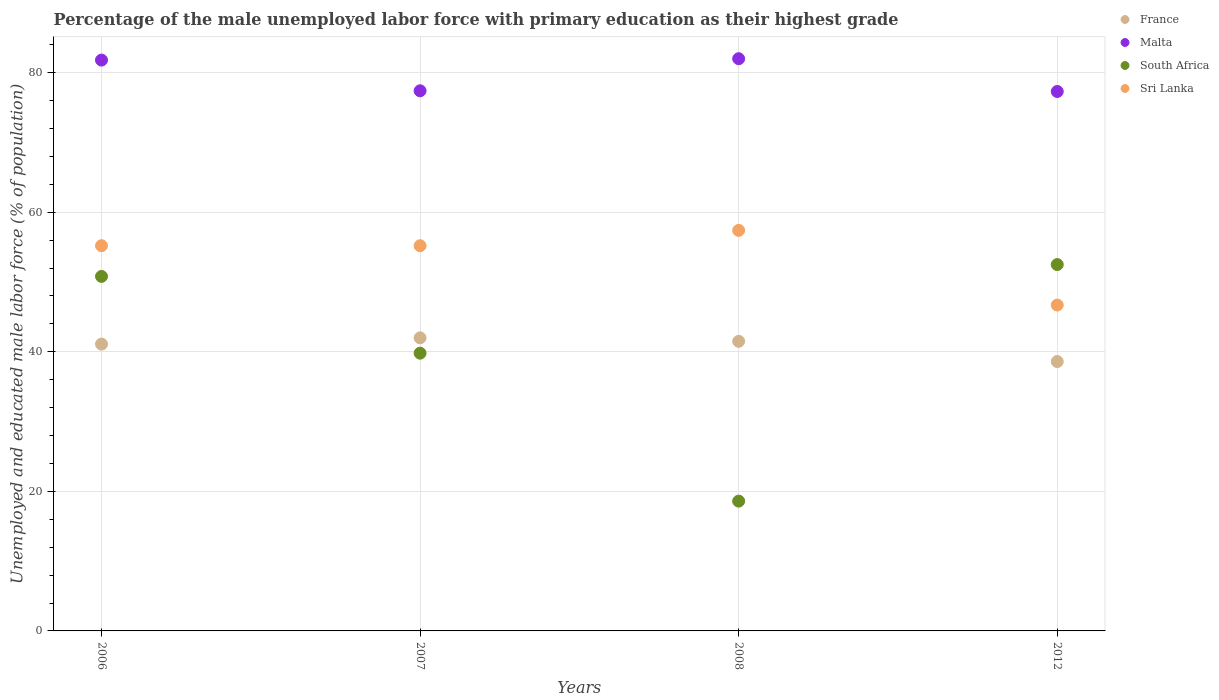Is the number of dotlines equal to the number of legend labels?
Offer a terse response. Yes. What is the percentage of the unemployed male labor force with primary education in Malta in 2006?
Offer a very short reply. 81.8. Across all years, what is the maximum percentage of the unemployed male labor force with primary education in South Africa?
Keep it short and to the point. 52.5. Across all years, what is the minimum percentage of the unemployed male labor force with primary education in Sri Lanka?
Provide a succinct answer. 46.7. In which year was the percentage of the unemployed male labor force with primary education in Sri Lanka maximum?
Make the answer very short. 2008. In which year was the percentage of the unemployed male labor force with primary education in Sri Lanka minimum?
Provide a short and direct response. 2012. What is the total percentage of the unemployed male labor force with primary education in Sri Lanka in the graph?
Your answer should be compact. 214.5. What is the difference between the percentage of the unemployed male labor force with primary education in France in 2006 and that in 2012?
Give a very brief answer. 2.5. What is the difference between the percentage of the unemployed male labor force with primary education in France in 2006 and the percentage of the unemployed male labor force with primary education in Sri Lanka in 2007?
Your response must be concise. -14.1. What is the average percentage of the unemployed male labor force with primary education in South Africa per year?
Offer a terse response. 40.42. In the year 2006, what is the difference between the percentage of the unemployed male labor force with primary education in France and percentage of the unemployed male labor force with primary education in South Africa?
Provide a succinct answer. -9.7. What is the ratio of the percentage of the unemployed male labor force with primary education in France in 2006 to that in 2008?
Ensure brevity in your answer.  0.99. Is the difference between the percentage of the unemployed male labor force with primary education in France in 2007 and 2012 greater than the difference between the percentage of the unemployed male labor force with primary education in South Africa in 2007 and 2012?
Ensure brevity in your answer.  Yes. What is the difference between the highest and the second highest percentage of the unemployed male labor force with primary education in Malta?
Your response must be concise. 0.2. What is the difference between the highest and the lowest percentage of the unemployed male labor force with primary education in South Africa?
Keep it short and to the point. 33.9. Is it the case that in every year, the sum of the percentage of the unemployed male labor force with primary education in South Africa and percentage of the unemployed male labor force with primary education in Malta  is greater than the sum of percentage of the unemployed male labor force with primary education in France and percentage of the unemployed male labor force with primary education in Sri Lanka?
Keep it short and to the point. Yes. Is it the case that in every year, the sum of the percentage of the unemployed male labor force with primary education in South Africa and percentage of the unemployed male labor force with primary education in Sri Lanka  is greater than the percentage of the unemployed male labor force with primary education in Malta?
Keep it short and to the point. No. Does the percentage of the unemployed male labor force with primary education in Sri Lanka monotonically increase over the years?
Your answer should be compact. No. How many dotlines are there?
Provide a short and direct response. 4. What is the difference between two consecutive major ticks on the Y-axis?
Your response must be concise. 20. Does the graph contain any zero values?
Provide a succinct answer. No. Does the graph contain grids?
Ensure brevity in your answer.  Yes. Where does the legend appear in the graph?
Provide a short and direct response. Top right. How are the legend labels stacked?
Offer a very short reply. Vertical. What is the title of the graph?
Your response must be concise. Percentage of the male unemployed labor force with primary education as their highest grade. What is the label or title of the Y-axis?
Ensure brevity in your answer.  Unemployed and educated male labor force (% of population). What is the Unemployed and educated male labor force (% of population) in France in 2006?
Give a very brief answer. 41.1. What is the Unemployed and educated male labor force (% of population) of Malta in 2006?
Ensure brevity in your answer.  81.8. What is the Unemployed and educated male labor force (% of population) of South Africa in 2006?
Your response must be concise. 50.8. What is the Unemployed and educated male labor force (% of population) in Sri Lanka in 2006?
Your answer should be compact. 55.2. What is the Unemployed and educated male labor force (% of population) of Malta in 2007?
Give a very brief answer. 77.4. What is the Unemployed and educated male labor force (% of population) in South Africa in 2007?
Provide a succinct answer. 39.8. What is the Unemployed and educated male labor force (% of population) in Sri Lanka in 2007?
Offer a very short reply. 55.2. What is the Unemployed and educated male labor force (% of population) in France in 2008?
Offer a very short reply. 41.5. What is the Unemployed and educated male labor force (% of population) of South Africa in 2008?
Keep it short and to the point. 18.6. What is the Unemployed and educated male labor force (% of population) in Sri Lanka in 2008?
Offer a very short reply. 57.4. What is the Unemployed and educated male labor force (% of population) in France in 2012?
Give a very brief answer. 38.6. What is the Unemployed and educated male labor force (% of population) in Malta in 2012?
Ensure brevity in your answer.  77.3. What is the Unemployed and educated male labor force (% of population) in South Africa in 2012?
Provide a succinct answer. 52.5. What is the Unemployed and educated male labor force (% of population) of Sri Lanka in 2012?
Your answer should be compact. 46.7. Across all years, what is the maximum Unemployed and educated male labor force (% of population) in Malta?
Your answer should be compact. 82. Across all years, what is the maximum Unemployed and educated male labor force (% of population) of South Africa?
Ensure brevity in your answer.  52.5. Across all years, what is the maximum Unemployed and educated male labor force (% of population) of Sri Lanka?
Give a very brief answer. 57.4. Across all years, what is the minimum Unemployed and educated male labor force (% of population) of France?
Ensure brevity in your answer.  38.6. Across all years, what is the minimum Unemployed and educated male labor force (% of population) of Malta?
Provide a succinct answer. 77.3. Across all years, what is the minimum Unemployed and educated male labor force (% of population) in South Africa?
Your answer should be compact. 18.6. Across all years, what is the minimum Unemployed and educated male labor force (% of population) in Sri Lanka?
Make the answer very short. 46.7. What is the total Unemployed and educated male labor force (% of population) of France in the graph?
Your answer should be very brief. 163.2. What is the total Unemployed and educated male labor force (% of population) in Malta in the graph?
Your answer should be compact. 318.5. What is the total Unemployed and educated male labor force (% of population) in South Africa in the graph?
Your response must be concise. 161.7. What is the total Unemployed and educated male labor force (% of population) in Sri Lanka in the graph?
Provide a short and direct response. 214.5. What is the difference between the Unemployed and educated male labor force (% of population) in Malta in 2006 and that in 2007?
Your answer should be very brief. 4.4. What is the difference between the Unemployed and educated male labor force (% of population) in Sri Lanka in 2006 and that in 2007?
Ensure brevity in your answer.  0. What is the difference between the Unemployed and educated male labor force (% of population) in France in 2006 and that in 2008?
Your answer should be very brief. -0.4. What is the difference between the Unemployed and educated male labor force (% of population) in Malta in 2006 and that in 2008?
Make the answer very short. -0.2. What is the difference between the Unemployed and educated male labor force (% of population) in South Africa in 2006 and that in 2008?
Offer a terse response. 32.2. What is the difference between the Unemployed and educated male labor force (% of population) in France in 2006 and that in 2012?
Provide a succinct answer. 2.5. What is the difference between the Unemployed and educated male labor force (% of population) of South Africa in 2006 and that in 2012?
Provide a succinct answer. -1.7. What is the difference between the Unemployed and educated male labor force (% of population) in Sri Lanka in 2006 and that in 2012?
Give a very brief answer. 8.5. What is the difference between the Unemployed and educated male labor force (% of population) in Malta in 2007 and that in 2008?
Offer a terse response. -4.6. What is the difference between the Unemployed and educated male labor force (% of population) in South Africa in 2007 and that in 2008?
Offer a terse response. 21.2. What is the difference between the Unemployed and educated male labor force (% of population) in France in 2007 and that in 2012?
Your answer should be very brief. 3.4. What is the difference between the Unemployed and educated male labor force (% of population) in Sri Lanka in 2007 and that in 2012?
Make the answer very short. 8.5. What is the difference between the Unemployed and educated male labor force (% of population) of France in 2008 and that in 2012?
Your response must be concise. 2.9. What is the difference between the Unemployed and educated male labor force (% of population) in South Africa in 2008 and that in 2012?
Make the answer very short. -33.9. What is the difference between the Unemployed and educated male labor force (% of population) in Sri Lanka in 2008 and that in 2012?
Give a very brief answer. 10.7. What is the difference between the Unemployed and educated male labor force (% of population) in France in 2006 and the Unemployed and educated male labor force (% of population) in Malta in 2007?
Provide a short and direct response. -36.3. What is the difference between the Unemployed and educated male labor force (% of population) of France in 2006 and the Unemployed and educated male labor force (% of population) of South Africa in 2007?
Make the answer very short. 1.3. What is the difference between the Unemployed and educated male labor force (% of population) in France in 2006 and the Unemployed and educated male labor force (% of population) in Sri Lanka in 2007?
Offer a very short reply. -14.1. What is the difference between the Unemployed and educated male labor force (% of population) in Malta in 2006 and the Unemployed and educated male labor force (% of population) in South Africa in 2007?
Your response must be concise. 42. What is the difference between the Unemployed and educated male labor force (% of population) of Malta in 2006 and the Unemployed and educated male labor force (% of population) of Sri Lanka in 2007?
Provide a succinct answer. 26.6. What is the difference between the Unemployed and educated male labor force (% of population) in France in 2006 and the Unemployed and educated male labor force (% of population) in Malta in 2008?
Your answer should be very brief. -40.9. What is the difference between the Unemployed and educated male labor force (% of population) of France in 2006 and the Unemployed and educated male labor force (% of population) of South Africa in 2008?
Offer a terse response. 22.5. What is the difference between the Unemployed and educated male labor force (% of population) of France in 2006 and the Unemployed and educated male labor force (% of population) of Sri Lanka in 2008?
Your response must be concise. -16.3. What is the difference between the Unemployed and educated male labor force (% of population) of Malta in 2006 and the Unemployed and educated male labor force (% of population) of South Africa in 2008?
Give a very brief answer. 63.2. What is the difference between the Unemployed and educated male labor force (% of population) in Malta in 2006 and the Unemployed and educated male labor force (% of population) in Sri Lanka in 2008?
Offer a very short reply. 24.4. What is the difference between the Unemployed and educated male labor force (% of population) of South Africa in 2006 and the Unemployed and educated male labor force (% of population) of Sri Lanka in 2008?
Ensure brevity in your answer.  -6.6. What is the difference between the Unemployed and educated male labor force (% of population) in France in 2006 and the Unemployed and educated male labor force (% of population) in Malta in 2012?
Your response must be concise. -36.2. What is the difference between the Unemployed and educated male labor force (% of population) in France in 2006 and the Unemployed and educated male labor force (% of population) in South Africa in 2012?
Ensure brevity in your answer.  -11.4. What is the difference between the Unemployed and educated male labor force (% of population) of Malta in 2006 and the Unemployed and educated male labor force (% of population) of South Africa in 2012?
Keep it short and to the point. 29.3. What is the difference between the Unemployed and educated male labor force (% of population) of Malta in 2006 and the Unemployed and educated male labor force (% of population) of Sri Lanka in 2012?
Provide a succinct answer. 35.1. What is the difference between the Unemployed and educated male labor force (% of population) in France in 2007 and the Unemployed and educated male labor force (% of population) in Malta in 2008?
Offer a very short reply. -40. What is the difference between the Unemployed and educated male labor force (% of population) of France in 2007 and the Unemployed and educated male labor force (% of population) of South Africa in 2008?
Keep it short and to the point. 23.4. What is the difference between the Unemployed and educated male labor force (% of population) in France in 2007 and the Unemployed and educated male labor force (% of population) in Sri Lanka in 2008?
Make the answer very short. -15.4. What is the difference between the Unemployed and educated male labor force (% of population) in Malta in 2007 and the Unemployed and educated male labor force (% of population) in South Africa in 2008?
Provide a short and direct response. 58.8. What is the difference between the Unemployed and educated male labor force (% of population) of South Africa in 2007 and the Unemployed and educated male labor force (% of population) of Sri Lanka in 2008?
Ensure brevity in your answer.  -17.6. What is the difference between the Unemployed and educated male labor force (% of population) of France in 2007 and the Unemployed and educated male labor force (% of population) of Malta in 2012?
Ensure brevity in your answer.  -35.3. What is the difference between the Unemployed and educated male labor force (% of population) of Malta in 2007 and the Unemployed and educated male labor force (% of population) of South Africa in 2012?
Provide a short and direct response. 24.9. What is the difference between the Unemployed and educated male labor force (% of population) in Malta in 2007 and the Unemployed and educated male labor force (% of population) in Sri Lanka in 2012?
Provide a succinct answer. 30.7. What is the difference between the Unemployed and educated male labor force (% of population) of South Africa in 2007 and the Unemployed and educated male labor force (% of population) of Sri Lanka in 2012?
Your answer should be very brief. -6.9. What is the difference between the Unemployed and educated male labor force (% of population) in France in 2008 and the Unemployed and educated male labor force (% of population) in Malta in 2012?
Offer a very short reply. -35.8. What is the difference between the Unemployed and educated male labor force (% of population) of France in 2008 and the Unemployed and educated male labor force (% of population) of Sri Lanka in 2012?
Your answer should be compact. -5.2. What is the difference between the Unemployed and educated male labor force (% of population) of Malta in 2008 and the Unemployed and educated male labor force (% of population) of South Africa in 2012?
Offer a terse response. 29.5. What is the difference between the Unemployed and educated male labor force (% of population) in Malta in 2008 and the Unemployed and educated male labor force (% of population) in Sri Lanka in 2012?
Offer a very short reply. 35.3. What is the difference between the Unemployed and educated male labor force (% of population) of South Africa in 2008 and the Unemployed and educated male labor force (% of population) of Sri Lanka in 2012?
Offer a terse response. -28.1. What is the average Unemployed and educated male labor force (% of population) in France per year?
Offer a terse response. 40.8. What is the average Unemployed and educated male labor force (% of population) in Malta per year?
Ensure brevity in your answer.  79.62. What is the average Unemployed and educated male labor force (% of population) of South Africa per year?
Provide a succinct answer. 40.42. What is the average Unemployed and educated male labor force (% of population) in Sri Lanka per year?
Your answer should be very brief. 53.62. In the year 2006, what is the difference between the Unemployed and educated male labor force (% of population) in France and Unemployed and educated male labor force (% of population) in Malta?
Offer a very short reply. -40.7. In the year 2006, what is the difference between the Unemployed and educated male labor force (% of population) in France and Unemployed and educated male labor force (% of population) in Sri Lanka?
Offer a terse response. -14.1. In the year 2006, what is the difference between the Unemployed and educated male labor force (% of population) of Malta and Unemployed and educated male labor force (% of population) of Sri Lanka?
Keep it short and to the point. 26.6. In the year 2007, what is the difference between the Unemployed and educated male labor force (% of population) of France and Unemployed and educated male labor force (% of population) of Malta?
Ensure brevity in your answer.  -35.4. In the year 2007, what is the difference between the Unemployed and educated male labor force (% of population) in France and Unemployed and educated male labor force (% of population) in Sri Lanka?
Ensure brevity in your answer.  -13.2. In the year 2007, what is the difference between the Unemployed and educated male labor force (% of population) in Malta and Unemployed and educated male labor force (% of population) in South Africa?
Ensure brevity in your answer.  37.6. In the year 2007, what is the difference between the Unemployed and educated male labor force (% of population) in South Africa and Unemployed and educated male labor force (% of population) in Sri Lanka?
Make the answer very short. -15.4. In the year 2008, what is the difference between the Unemployed and educated male labor force (% of population) of France and Unemployed and educated male labor force (% of population) of Malta?
Provide a short and direct response. -40.5. In the year 2008, what is the difference between the Unemployed and educated male labor force (% of population) in France and Unemployed and educated male labor force (% of population) in South Africa?
Offer a very short reply. 22.9. In the year 2008, what is the difference between the Unemployed and educated male labor force (% of population) of France and Unemployed and educated male labor force (% of population) of Sri Lanka?
Your answer should be very brief. -15.9. In the year 2008, what is the difference between the Unemployed and educated male labor force (% of population) in Malta and Unemployed and educated male labor force (% of population) in South Africa?
Offer a terse response. 63.4. In the year 2008, what is the difference between the Unemployed and educated male labor force (% of population) of Malta and Unemployed and educated male labor force (% of population) of Sri Lanka?
Provide a succinct answer. 24.6. In the year 2008, what is the difference between the Unemployed and educated male labor force (% of population) of South Africa and Unemployed and educated male labor force (% of population) of Sri Lanka?
Give a very brief answer. -38.8. In the year 2012, what is the difference between the Unemployed and educated male labor force (% of population) in France and Unemployed and educated male labor force (% of population) in Malta?
Give a very brief answer. -38.7. In the year 2012, what is the difference between the Unemployed and educated male labor force (% of population) of Malta and Unemployed and educated male labor force (% of population) of South Africa?
Make the answer very short. 24.8. In the year 2012, what is the difference between the Unemployed and educated male labor force (% of population) of Malta and Unemployed and educated male labor force (% of population) of Sri Lanka?
Make the answer very short. 30.6. In the year 2012, what is the difference between the Unemployed and educated male labor force (% of population) of South Africa and Unemployed and educated male labor force (% of population) of Sri Lanka?
Offer a very short reply. 5.8. What is the ratio of the Unemployed and educated male labor force (% of population) of France in 2006 to that in 2007?
Provide a short and direct response. 0.98. What is the ratio of the Unemployed and educated male labor force (% of population) of Malta in 2006 to that in 2007?
Provide a succinct answer. 1.06. What is the ratio of the Unemployed and educated male labor force (% of population) in South Africa in 2006 to that in 2007?
Your response must be concise. 1.28. What is the ratio of the Unemployed and educated male labor force (% of population) in Malta in 2006 to that in 2008?
Provide a succinct answer. 1. What is the ratio of the Unemployed and educated male labor force (% of population) of South Africa in 2006 to that in 2008?
Your answer should be very brief. 2.73. What is the ratio of the Unemployed and educated male labor force (% of population) of Sri Lanka in 2006 to that in 2008?
Ensure brevity in your answer.  0.96. What is the ratio of the Unemployed and educated male labor force (% of population) of France in 2006 to that in 2012?
Give a very brief answer. 1.06. What is the ratio of the Unemployed and educated male labor force (% of population) of Malta in 2006 to that in 2012?
Provide a short and direct response. 1.06. What is the ratio of the Unemployed and educated male labor force (% of population) of South Africa in 2006 to that in 2012?
Provide a short and direct response. 0.97. What is the ratio of the Unemployed and educated male labor force (% of population) of Sri Lanka in 2006 to that in 2012?
Offer a terse response. 1.18. What is the ratio of the Unemployed and educated male labor force (% of population) in Malta in 2007 to that in 2008?
Ensure brevity in your answer.  0.94. What is the ratio of the Unemployed and educated male labor force (% of population) of South Africa in 2007 to that in 2008?
Your answer should be compact. 2.14. What is the ratio of the Unemployed and educated male labor force (% of population) in Sri Lanka in 2007 to that in 2008?
Your answer should be compact. 0.96. What is the ratio of the Unemployed and educated male labor force (% of population) in France in 2007 to that in 2012?
Keep it short and to the point. 1.09. What is the ratio of the Unemployed and educated male labor force (% of population) of Malta in 2007 to that in 2012?
Provide a succinct answer. 1. What is the ratio of the Unemployed and educated male labor force (% of population) in South Africa in 2007 to that in 2012?
Your response must be concise. 0.76. What is the ratio of the Unemployed and educated male labor force (% of population) of Sri Lanka in 2007 to that in 2012?
Your response must be concise. 1.18. What is the ratio of the Unemployed and educated male labor force (% of population) in France in 2008 to that in 2012?
Keep it short and to the point. 1.08. What is the ratio of the Unemployed and educated male labor force (% of population) in Malta in 2008 to that in 2012?
Give a very brief answer. 1.06. What is the ratio of the Unemployed and educated male labor force (% of population) in South Africa in 2008 to that in 2012?
Your response must be concise. 0.35. What is the ratio of the Unemployed and educated male labor force (% of population) in Sri Lanka in 2008 to that in 2012?
Offer a terse response. 1.23. What is the difference between the highest and the second highest Unemployed and educated male labor force (% of population) of Malta?
Give a very brief answer. 0.2. What is the difference between the highest and the lowest Unemployed and educated male labor force (% of population) in South Africa?
Keep it short and to the point. 33.9. 